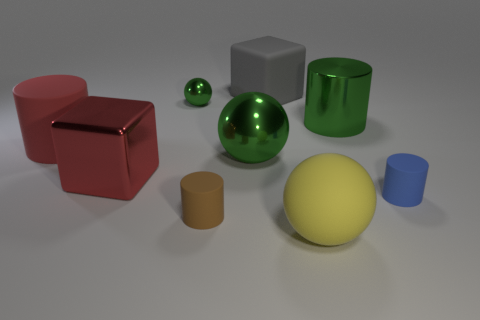Subtract all gray cylinders. Subtract all cyan spheres. How many cylinders are left? 4 Add 1 big green cylinders. How many objects exist? 10 Add 7 large red objects. How many large red objects exist? 9 Subtract 0 gray balls. How many objects are left? 9 Subtract all cubes. How many objects are left? 7 Subtract all red metallic blocks. Subtract all yellow matte balls. How many objects are left? 7 Add 7 matte spheres. How many matte spheres are left? 8 